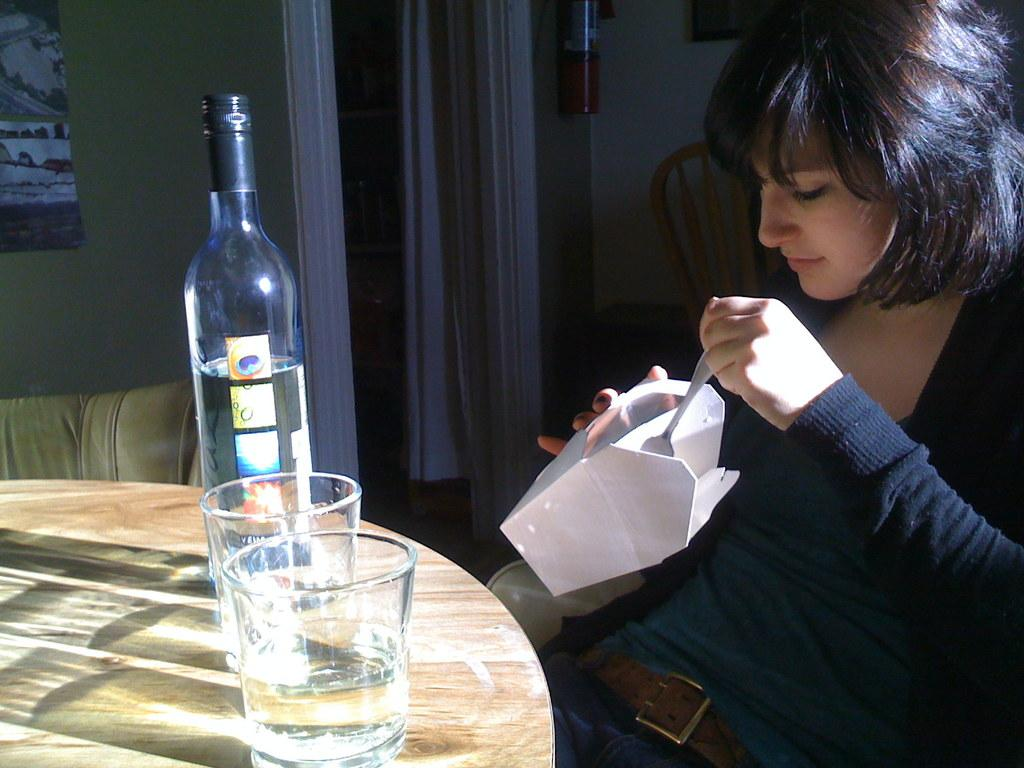What is the woman doing in the image? The woman is sitting on a chair in the image. What is in front of the woman? There is a table in front of the woman. What can be seen on the table? There is a glass and a bottle on the table. What can be seen in the background of the image? There is a wall, a frame, curtains, and another chair in the background of the image. What type of fruit is the woman holding in her hand in the image? There is no fruit visible in the woman's hand or anywhere else in the image. 